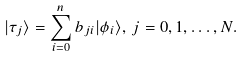Convert formula to latex. <formula><loc_0><loc_0><loc_500><loc_500>| \tau _ { j } \rangle = \sum _ { i = 0 } ^ { n } b _ { j i } | \phi _ { i } \rangle , \, j = 0 , 1 , \dots , N .</formula> 